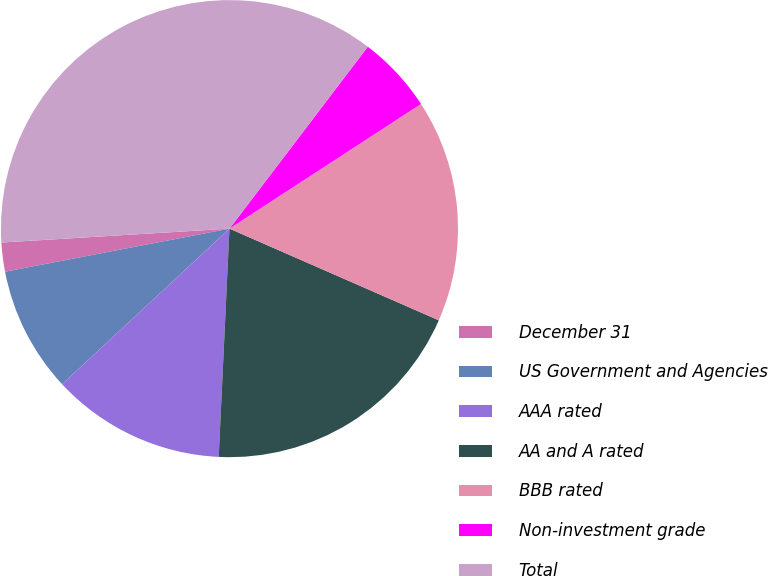Convert chart. <chart><loc_0><loc_0><loc_500><loc_500><pie_chart><fcel>December 31<fcel>US Government and Agencies<fcel>AAA rated<fcel>AA and A rated<fcel>BBB rated<fcel>Non-investment grade<fcel>Total<nl><fcel>2.05%<fcel>8.9%<fcel>12.33%<fcel>19.18%<fcel>15.75%<fcel>5.47%<fcel>36.31%<nl></chart> 